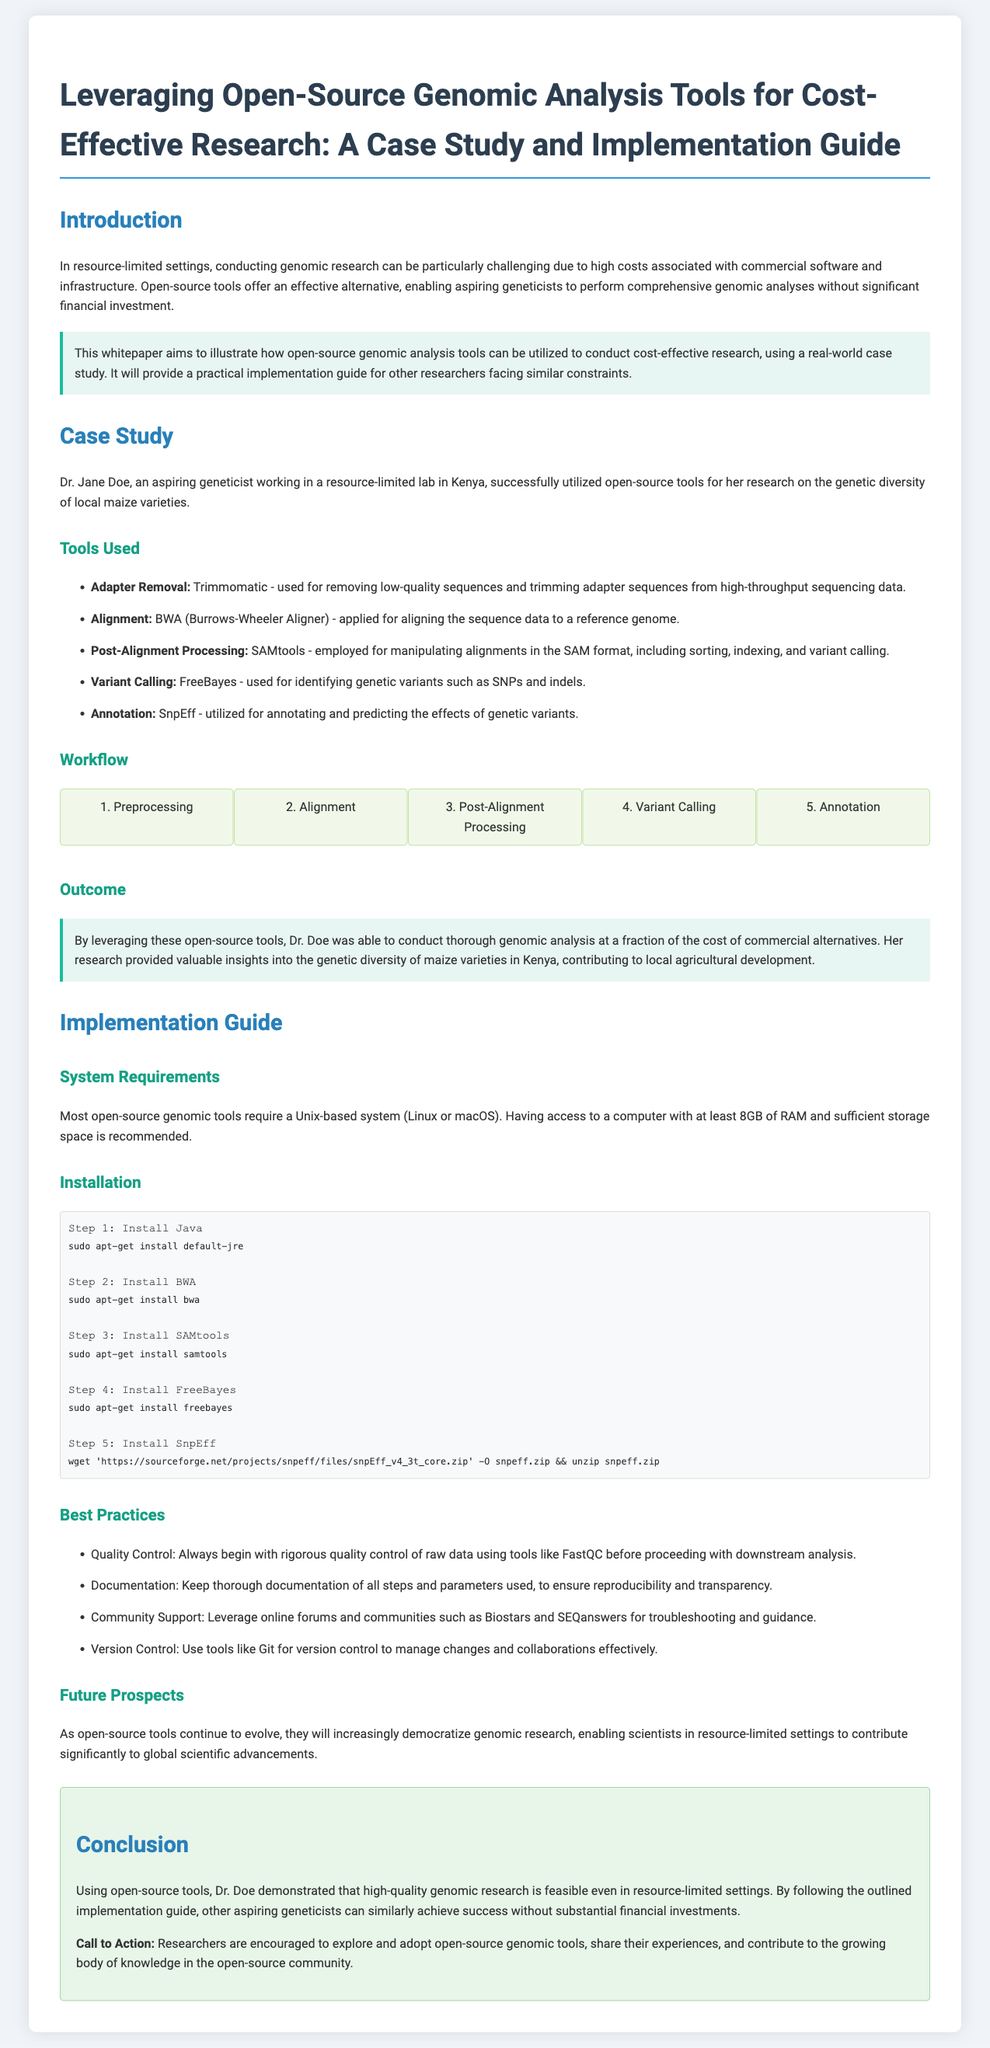what is the main focus of the whitepaper? The whitepaper focuses on leveraging open-source genomic analysis tools for cost-effective research.
Answer: leveraging open-source genomic analysis tools for cost-effective research who is the author of the case study presented in the whitepaper? The case study is authored by Dr. Jane Doe, an aspiring geneticist.
Answer: Dr. Jane Doe what is the first tool listed for adapter removal? The first tool mentioned for adapter removal is Trimmomatic.
Answer: Trimmomatic how many workflow steps are mentioned in the document? The document outlines five workflow steps in the genomic analysis process.
Answer: five which software is used for variant calling? FreeBayes is the software used for variant calling in the case study.
Answer: FreeBayes what is one of the best practices recommended in the whitepaper? One of the best practices recommended is to conduct rigorous quality control of raw data.
Answer: Quality Control what type of system is required for most open-source genomic tools? Most open-source genomic tools require a Unix-based system.
Answer: Unix-based system which online communities are suggested for support? The document suggests leveraging online forums such as Biostars and SEQanswers for support.
Answer: Biostars and SEQanswers what is the expected outcome of using open-source tools as mentioned in the whitepaper? The expected outcome is that high-quality genomic research is feasible in resource-limited settings.
Answer: high-quality genomic research is feasible in resource-limited settings 